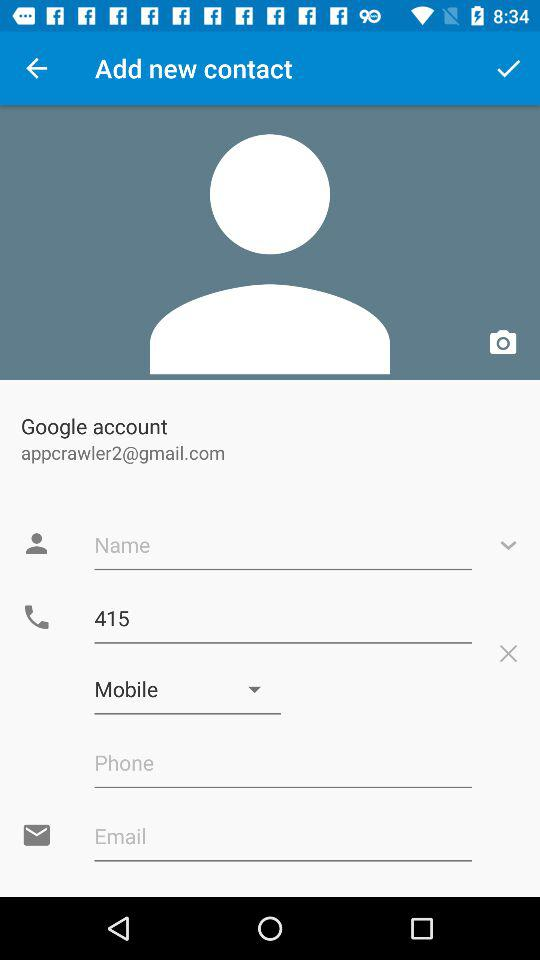What is the user's email ID? The user's email ID is appcrawler2@gmail.com. 